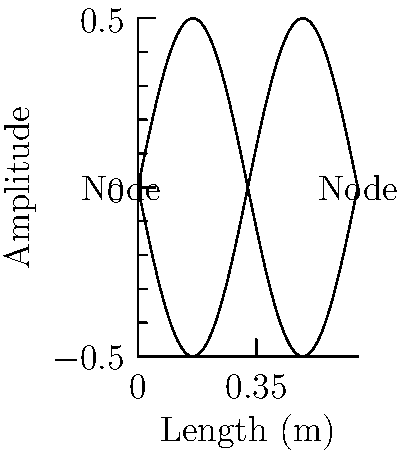Imagine you're tuning a guitar for your next samba performance. The low E string on a standard guitar has a length of 0.65 m and a linear mass density of 0.00175 kg/m. If the tension in the string is 75 N, what is the fundamental frequency of this string? (Assume the speed of sound in air is 343 m/s) Let's approach this step-by-step:

1) The fundamental frequency of a vibrating string is given by the formula:

   $$f = \frac{1}{2L}\sqrt{\frac{T}{\mu}}$$

   where $f$ is the frequency, $L$ is the length of the string, $T$ is the tension, and $\mu$ is the linear mass density.

2) We're given:
   $L = 0.65$ m
   $\mu = 0.00175$ kg/m
   $T = 75$ N

3) Let's substitute these values into our equation:

   $$f = \frac{1}{2(0.65)}\sqrt{\frac{75}{0.00175}}$$

4) Let's solve what's inside the square root first:
   
   $$\frac{75}{0.00175} = 42,857.14$$

5) Now our equation looks like:

   $$f = \frac{1}{1.3}\sqrt{42,857.14}$$

6) Solving the square root:

   $$f = \frac{1}{1.3}(207.02)$$

7) Final calculation:

   $$f = 159.25 \text{ Hz}$$

8) Rounding to the nearest whole number:

   $$f \approx 159 \text{ Hz}$$

This frequency corresponds to a note slightly below E3 (164.81 Hz), which is appropriate for the low E string on a guitar.
Answer: 159 Hz 